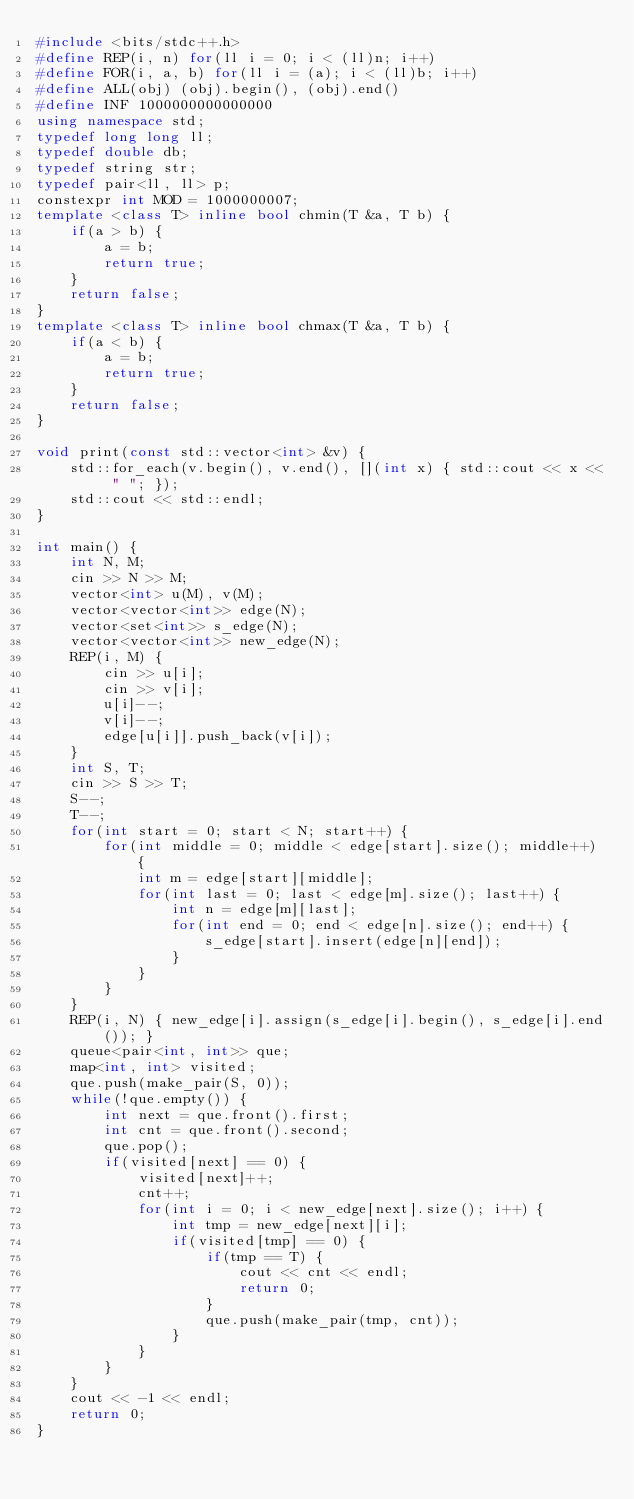Convert code to text. <code><loc_0><loc_0><loc_500><loc_500><_C++_>#include <bits/stdc++.h>
#define REP(i, n) for(ll i = 0; i < (ll)n; i++)
#define FOR(i, a, b) for(ll i = (a); i < (ll)b; i++)
#define ALL(obj) (obj).begin(), (obj).end()
#define INF 1000000000000000
using namespace std;
typedef long long ll;
typedef double db;
typedef string str;
typedef pair<ll, ll> p;
constexpr int MOD = 1000000007;
template <class T> inline bool chmin(T &a, T b) {
    if(a > b) {
        a = b;
        return true;
    }
    return false;
}
template <class T> inline bool chmax(T &a, T b) {
    if(a < b) {
        a = b;
        return true;
    }
    return false;
}

void print(const std::vector<int> &v) {
    std::for_each(v.begin(), v.end(), [](int x) { std::cout << x << " "; });
    std::cout << std::endl;
}

int main() {
    int N, M;
    cin >> N >> M;
    vector<int> u(M), v(M);
    vector<vector<int>> edge(N);
    vector<set<int>> s_edge(N);
    vector<vector<int>> new_edge(N);
    REP(i, M) {
        cin >> u[i];
        cin >> v[i];
        u[i]--;
        v[i]--;
        edge[u[i]].push_back(v[i]);
    }
    int S, T;
    cin >> S >> T;
    S--;
    T--;
    for(int start = 0; start < N; start++) {
        for(int middle = 0; middle < edge[start].size(); middle++) {
            int m = edge[start][middle];
            for(int last = 0; last < edge[m].size(); last++) {
                int n = edge[m][last];
                for(int end = 0; end < edge[n].size(); end++) {
                    s_edge[start].insert(edge[n][end]);
                }
            }
        }
    }
    REP(i, N) { new_edge[i].assign(s_edge[i].begin(), s_edge[i].end()); }
    queue<pair<int, int>> que;
    map<int, int> visited;
    que.push(make_pair(S, 0));
    while(!que.empty()) {
        int next = que.front().first;
        int cnt = que.front().second;
        que.pop();
        if(visited[next] == 0) {
            visited[next]++;
            cnt++;
            for(int i = 0; i < new_edge[next].size(); i++) {
                int tmp = new_edge[next][i];
                if(visited[tmp] == 0) {
                    if(tmp == T) {
                        cout << cnt << endl;
                        return 0;
                    }
                    que.push(make_pair(tmp, cnt));
                }
            }
        }
    }
    cout << -1 << endl;
    return 0;
}</code> 